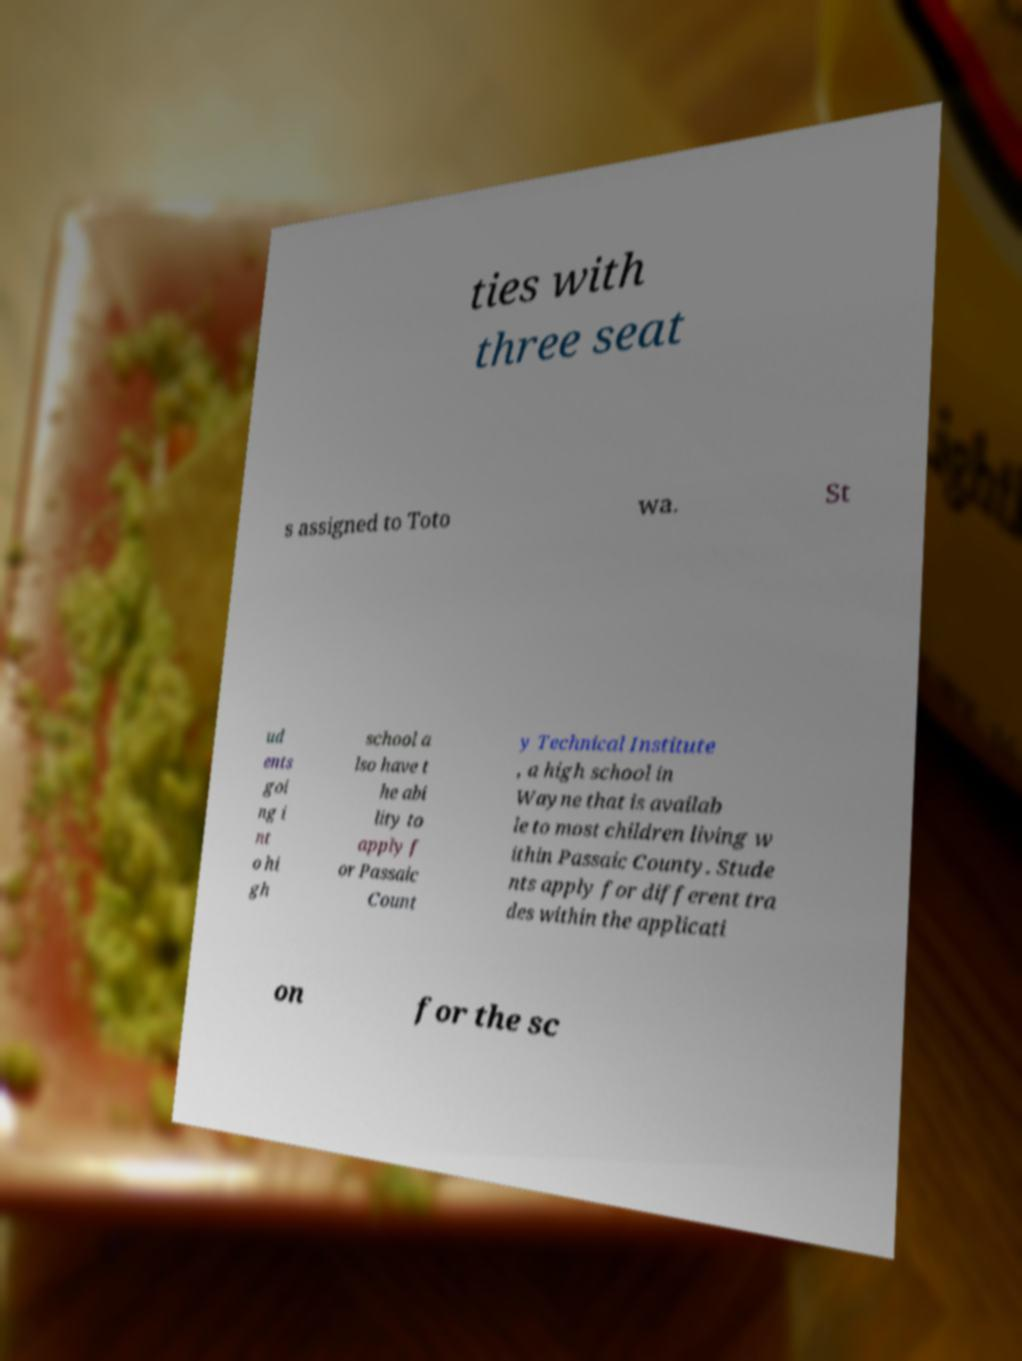What messages or text are displayed in this image? I need them in a readable, typed format. ties with three seat s assigned to Toto wa. St ud ents goi ng i nt o hi gh school a lso have t he abi lity to apply f or Passaic Count y Technical Institute , a high school in Wayne that is availab le to most children living w ithin Passaic County. Stude nts apply for different tra des within the applicati on for the sc 